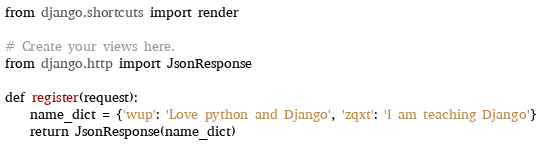<code> <loc_0><loc_0><loc_500><loc_500><_Python_>from django.shortcuts import render

# Create your views here.
from django.http import JsonResponse

def register(request):
    name_dict = {'wup': 'Love python and Django', 'zqxt': 'I am teaching Django'}
    return JsonResponse(name_dict)
</code> 